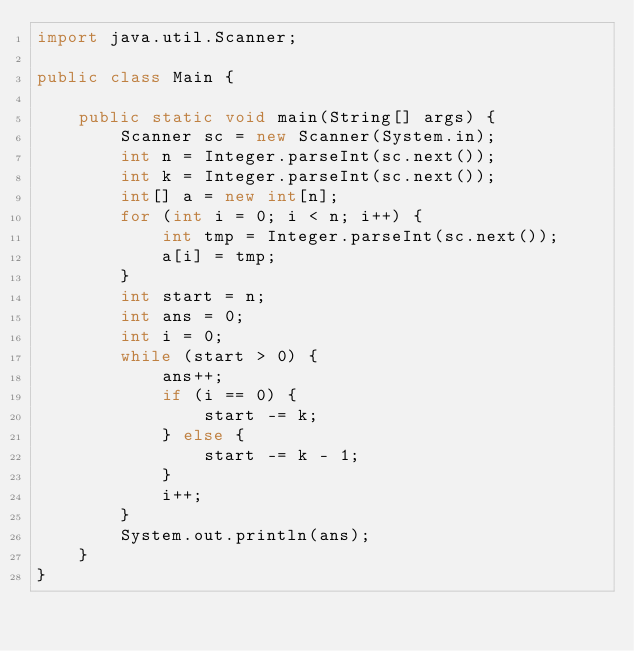<code> <loc_0><loc_0><loc_500><loc_500><_Java_>import java.util.Scanner;

public class Main {

    public static void main(String[] args) {
        Scanner sc = new Scanner(System.in);
        int n = Integer.parseInt(sc.next());
        int k = Integer.parseInt(sc.next());
        int[] a = new int[n];
        for (int i = 0; i < n; i++) {
            int tmp = Integer.parseInt(sc.next());
            a[i] = tmp;
        }
        int start = n;
        int ans = 0;
        int i = 0;
        while (start > 0) {
            ans++;
            if (i == 0) {
                start -= k;
            } else {
                start -= k - 1;
            }
            i++;
        }
        System.out.println(ans);
    }
}</code> 